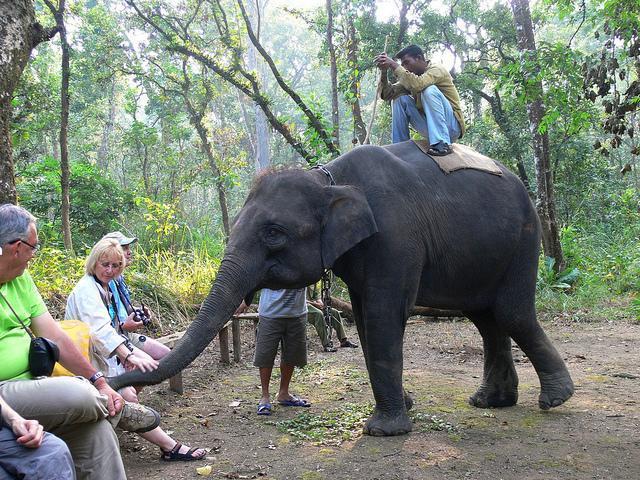What other animal is this animal traditionally afraid of?
Choose the right answer and clarify with the format: 'Answer: answer
Rationale: rationale.'
Options: Tigers, rhinos, cats, mice. Answer: mice.
Rationale: Elephants, though large, tend to get scared of really, really, really fast small things. 